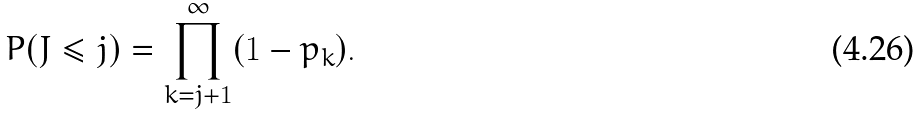Convert formula to latex. <formula><loc_0><loc_0><loc_500><loc_500>P ( J \leq j ) = \prod _ { k = j + 1 } ^ { \infty } ( 1 - p _ { k } ) .</formula> 